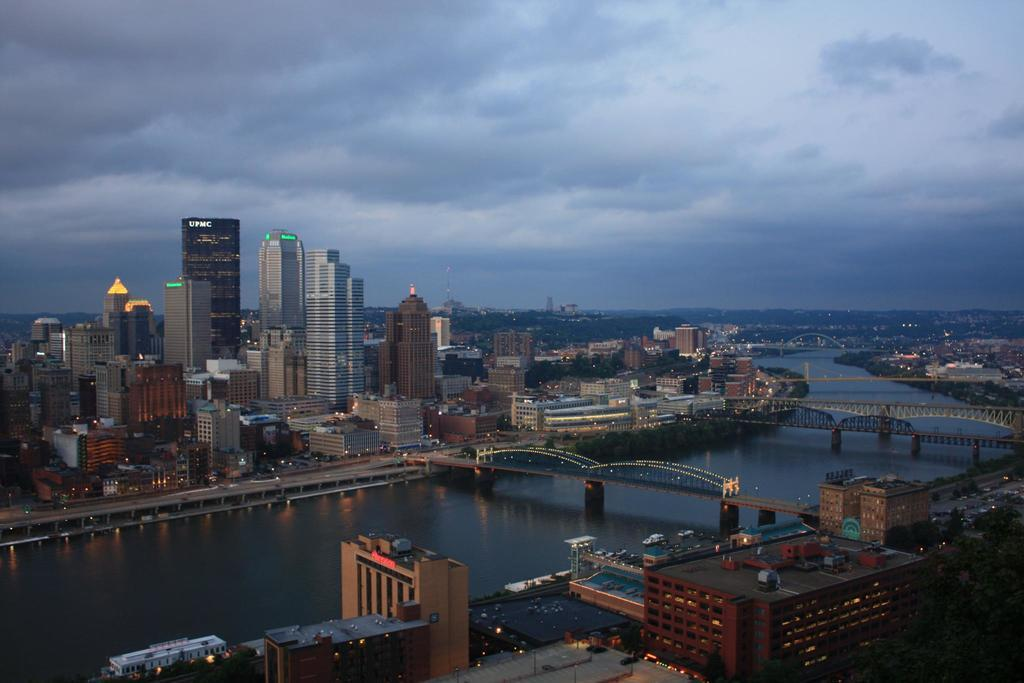What type of location is shown in the image? The image depicts a city. What structures can be seen in the city? There are many buildings and houses in the city. How is the city divided? The city is divided into two parts by a river. How do people cross the river in the city? There are bridges across the river in the city. Can you see any goldfish swimming in the river in the image? There are no goldfish visible in the image; it depicts a city with a river and bridges. Are there any tents set up in the city for people to stay in? There is no mention of tents in the image; it shows a city with buildings, houses, a river, and bridges. 